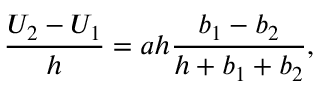Convert formula to latex. <formula><loc_0><loc_0><loc_500><loc_500>\frac { U _ { 2 } - U _ { 1 } } { h } = a h \frac { b _ { 1 } - b _ { 2 } } { h + b _ { 1 } + b _ { 2 } } ,</formula> 